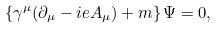<formula> <loc_0><loc_0><loc_500><loc_500>\left \{ \gamma ^ { \mu } ( \partial _ { \mu } - i e A _ { \mu } ) + m \right \} \Psi = 0 ,</formula> 